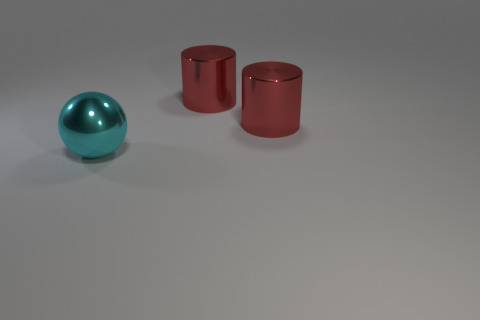How many objects are either cyan matte cubes or red cylinders?
Keep it short and to the point. 2. What number of things are either metal things that are to the right of the big cyan thing or large shiny objects on the right side of the big metal sphere?
Your response must be concise. 2. The cyan thing is what shape?
Provide a succinct answer. Sphere. How many other things are the same material as the cyan object?
Your answer should be compact. 2. What number of other things are the same size as the sphere?
Make the answer very short. 2. Is the number of red metallic cylinders that are to the right of the big cyan sphere greater than the number of large cyan spheres?
Give a very brief answer. Yes. How many objects are large shiny things to the right of the cyan sphere or cyan shiny balls?
Offer a terse response. 3. How many small things are cubes or cyan objects?
Give a very brief answer. 0. Are any cyan balls visible?
Keep it short and to the point. Yes. How many red cylinders are the same size as the cyan thing?
Offer a very short reply. 2. 